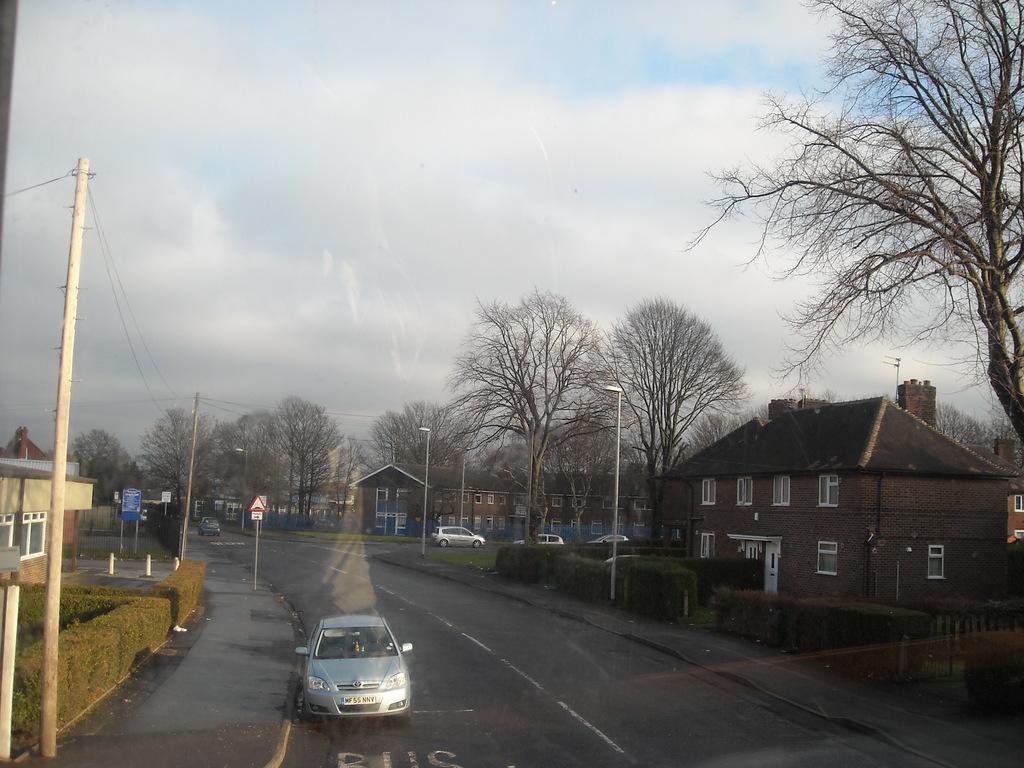Please provide a concise description of this image. In this image we can see a few vehicles on the road, houses, windows, plants, dried trees, electrical poles, street lights, at the top we can see the sky with clouds. 